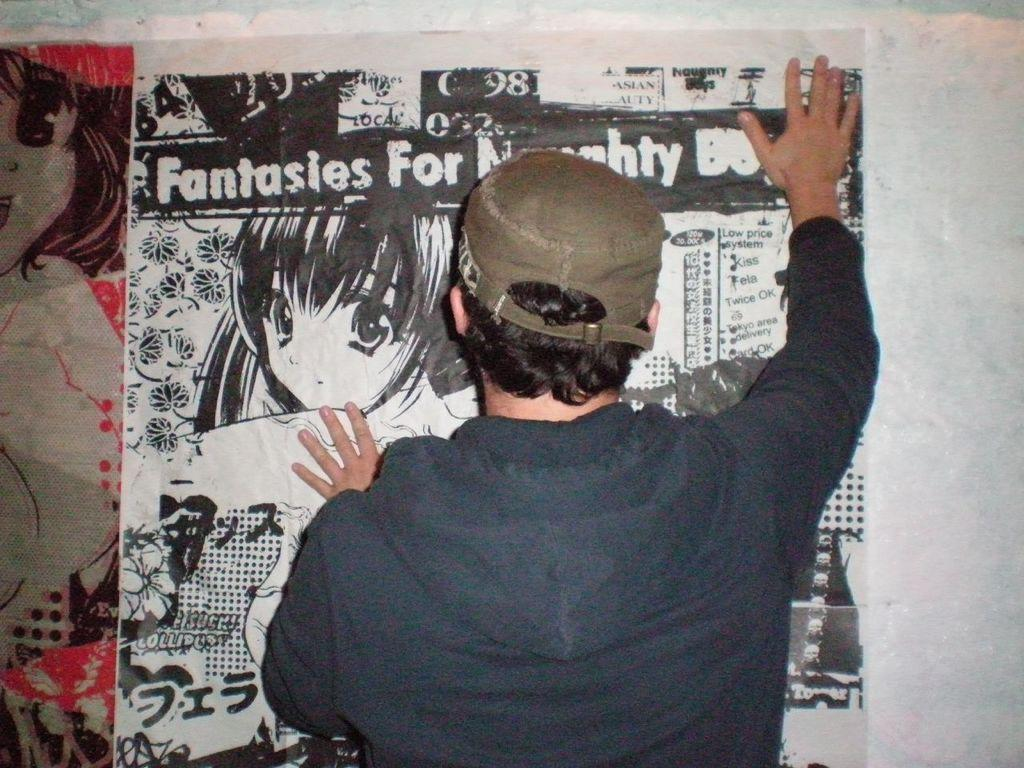Who is present in the image? There is a person in the image. What is the person wearing? The person is wearing a cap. What is the person doing in the image? The person is holding a poster on the wall. What can be found on the poster? The poster contains pictures and text. What type of zebra can be seen playing a guitar on the edge of the poster? There is no zebra or guitar present on the poster; it contains pictures and text related to other subjects. 